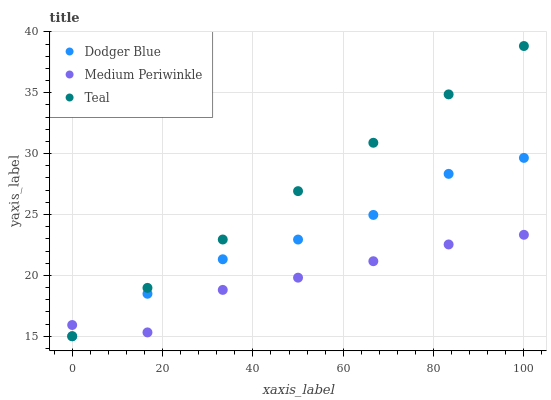Does Medium Periwinkle have the minimum area under the curve?
Answer yes or no. Yes. Does Teal have the maximum area under the curve?
Answer yes or no. Yes. Does Dodger Blue have the minimum area under the curve?
Answer yes or no. No. Does Dodger Blue have the maximum area under the curve?
Answer yes or no. No. Is Teal the smoothest?
Answer yes or no. Yes. Is Medium Periwinkle the roughest?
Answer yes or no. Yes. Is Dodger Blue the smoothest?
Answer yes or no. No. Is Dodger Blue the roughest?
Answer yes or no. No. Does Teal have the lowest value?
Answer yes or no. Yes. Does Dodger Blue have the lowest value?
Answer yes or no. No. Does Teal have the highest value?
Answer yes or no. Yes. Does Dodger Blue have the highest value?
Answer yes or no. No. Does Medium Periwinkle intersect Dodger Blue?
Answer yes or no. Yes. Is Medium Periwinkle less than Dodger Blue?
Answer yes or no. No. Is Medium Periwinkle greater than Dodger Blue?
Answer yes or no. No. 